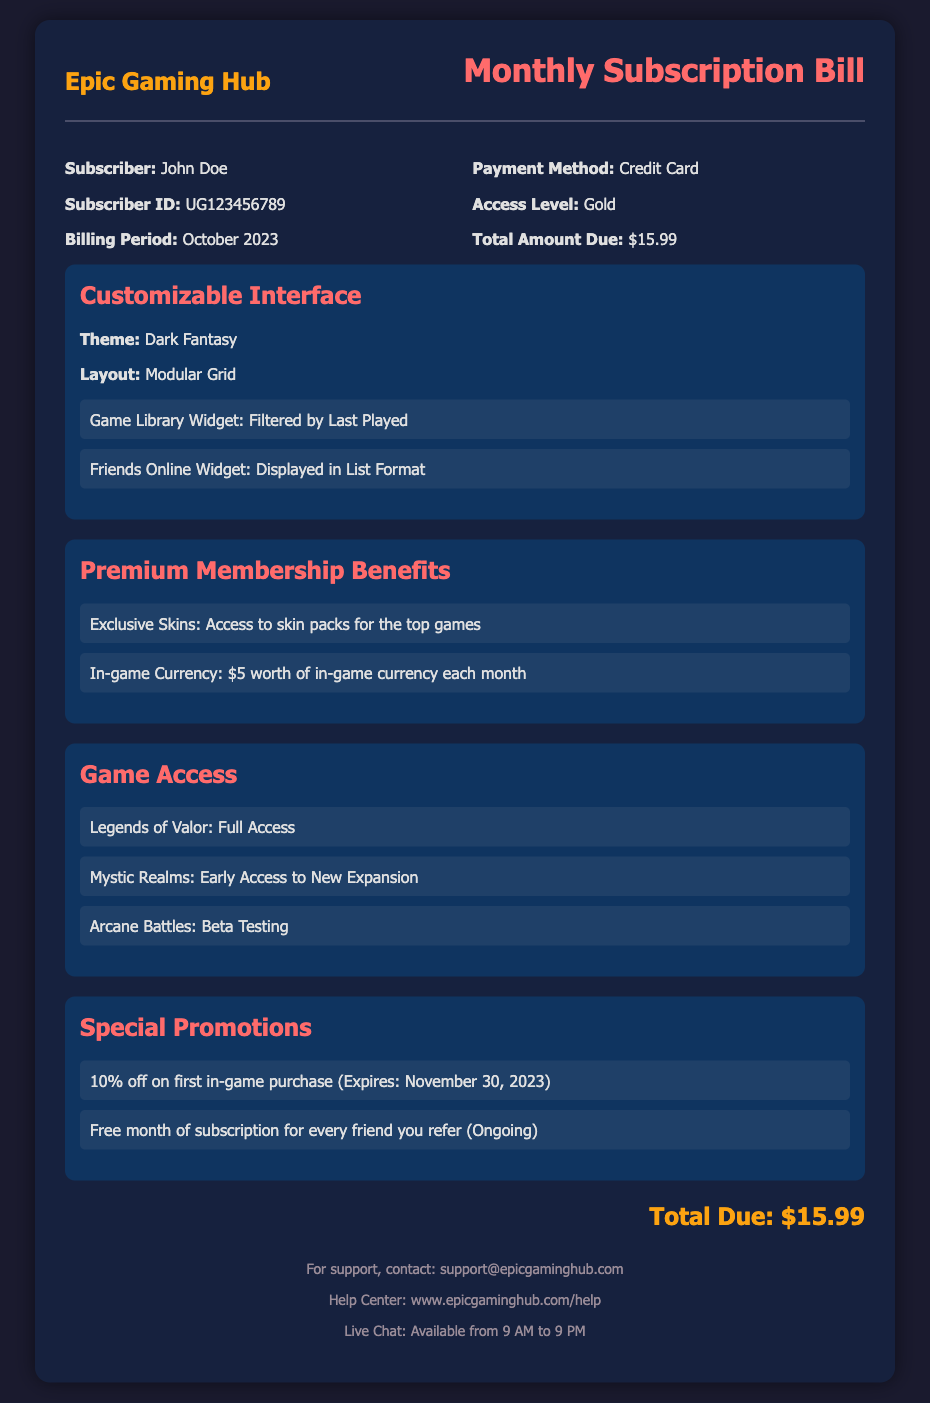What is the subscriber's name? The document specifies that the subscriber is John Doe.
Answer: John Doe What is the payment method? The payment method listed in the document is Credit Card.
Answer: Credit Card What is the billing period? The document states that the billing period is October 2023.
Answer: October 2023 How much is the total amount due? The total amount due, as mentioned in the document, is $15.99.
Answer: $15.99 What is one benefit of premium membership? The document lists the benefit of exclusive skins for top games as a premium membership perk.
Answer: Exclusive Skins What theme is used for the customizable interface? The document indicates that the theme for the customizable interface is Dark Fantasy.
Answer: Dark Fantasy Which game has early access to a new expansion? Mystic Realms is specified to have early access to a new expansion.
Answer: Mystic Realms What is the discount percentage for the first in-game purchase? The document mentions a 10% discount for the first in-game purchase.
Answer: 10% How can a subscriber get a free month of subscription? The document states that referring a friend yields a free month of subscription.
Answer: Refer a friend 